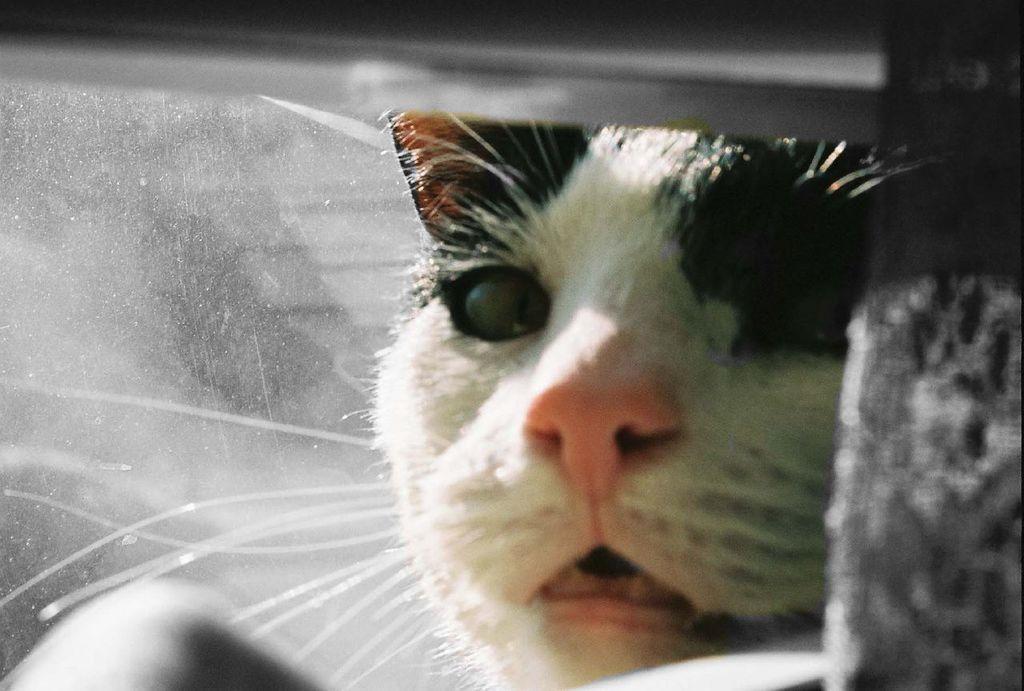How would you summarize this image in a sentence or two? In this picture we can see a cat and an object. 